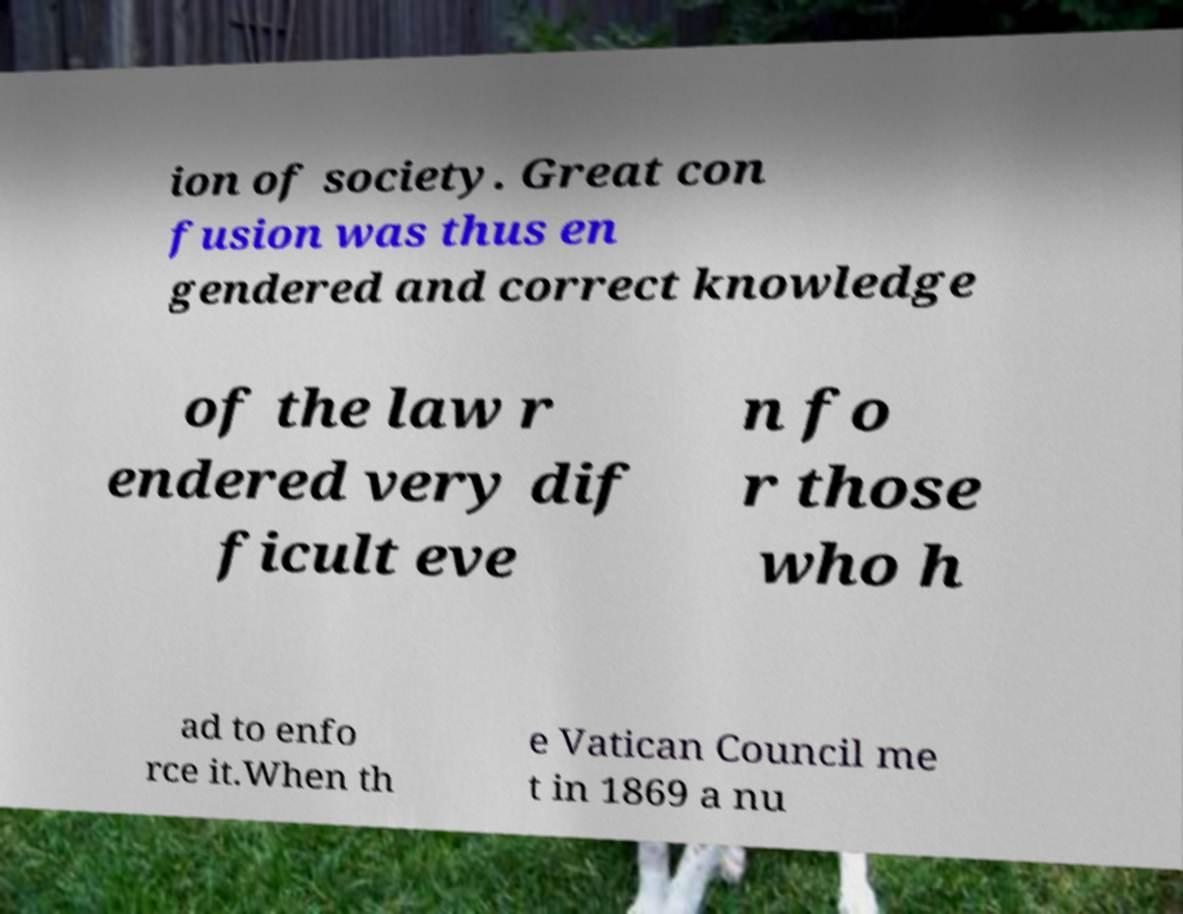I need the written content from this picture converted into text. Can you do that? ion of society. Great con fusion was thus en gendered and correct knowledge of the law r endered very dif ficult eve n fo r those who h ad to enfo rce it.When th e Vatican Council me t in 1869 a nu 